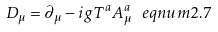<formula> <loc_0><loc_0><loc_500><loc_500>D _ { \mu } = \partial _ { \mu } - i g T ^ { a } A _ { \mu } ^ { a } \ e q n u m { 2 . 7 }</formula> 